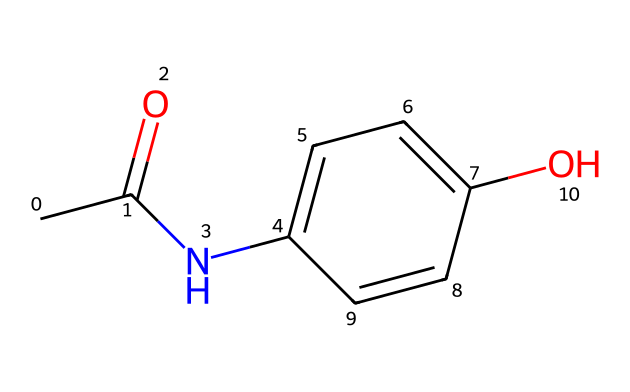What is the name of this chemical? The provided SMILES representation corresponds to the structure of paracetamol (acetaminophen), which is a well-known analgesic and antipyretic drug.
Answer: paracetamol How many carbon atoms are present? By examining the SMILES, there are six carbon atoms in the structure (CC(=O) indicates 2, NC1 denotes one more, and C=C represents two additional ones from the aromatic ring, totaling six).
Answer: six How many functional groups are identified in the structure? The structure has two functional groups: an amide group (from the NC portion) and a hydroxyl group (from the C1=CC...O portion). This indicates its nature as a drug.
Answer: two What is the main interaction type expected in paracetamol's mechanism of action? Paracetamol primarily exhibits non-covalent interactions, particularly hydrogen bonding, which is vital for binding to its target enzymes in the body.
Answer: hydrogen bonding Which element indicates the presence of a carbonyl group? The carbonyl group is present where the double bond to oxygen is indicated by the '=' in the CC(=O) part of the SMILES.
Answer: oxygen What property related to paracetamol is influenced by steric hindrance in its structure? The steric hindrance, especially from the aromatic ring and/ or the hydroxyl and amide groups, influences its solubility and bioavailability in the body.
Answer: solubility How does the structure indicate its role as a analgesic drug? The presence of the amide and hydroxyl functional groups, along with their spatial arrangement, allows paracetamol to effectively modulate pain signaling pathways, akin to optimizing algorithm paths for efficiency.
Answer: modulate pain 